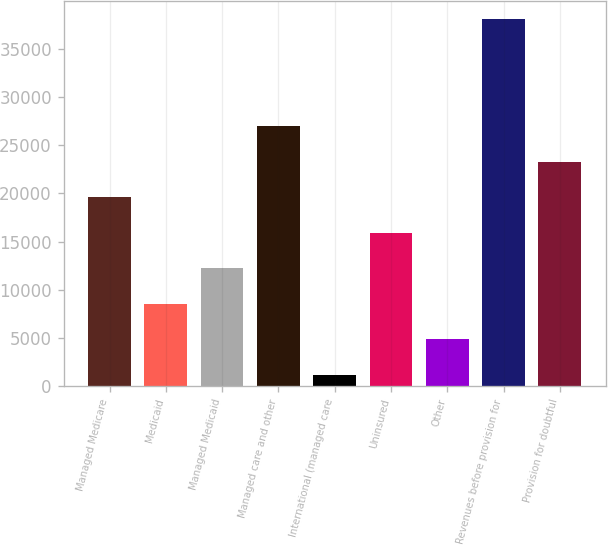<chart> <loc_0><loc_0><loc_500><loc_500><bar_chart><fcel>Managed Medicare<fcel>Medicaid<fcel>Managed Medicaid<fcel>Managed care and other<fcel>International (managed care<fcel>Uninsured<fcel>Other<fcel>Revenues before provision for<fcel>Provision for doubtful<nl><fcel>19607.5<fcel>8548<fcel>12234.5<fcel>26980.5<fcel>1175<fcel>15921<fcel>4861.5<fcel>38040<fcel>23294<nl></chart> 